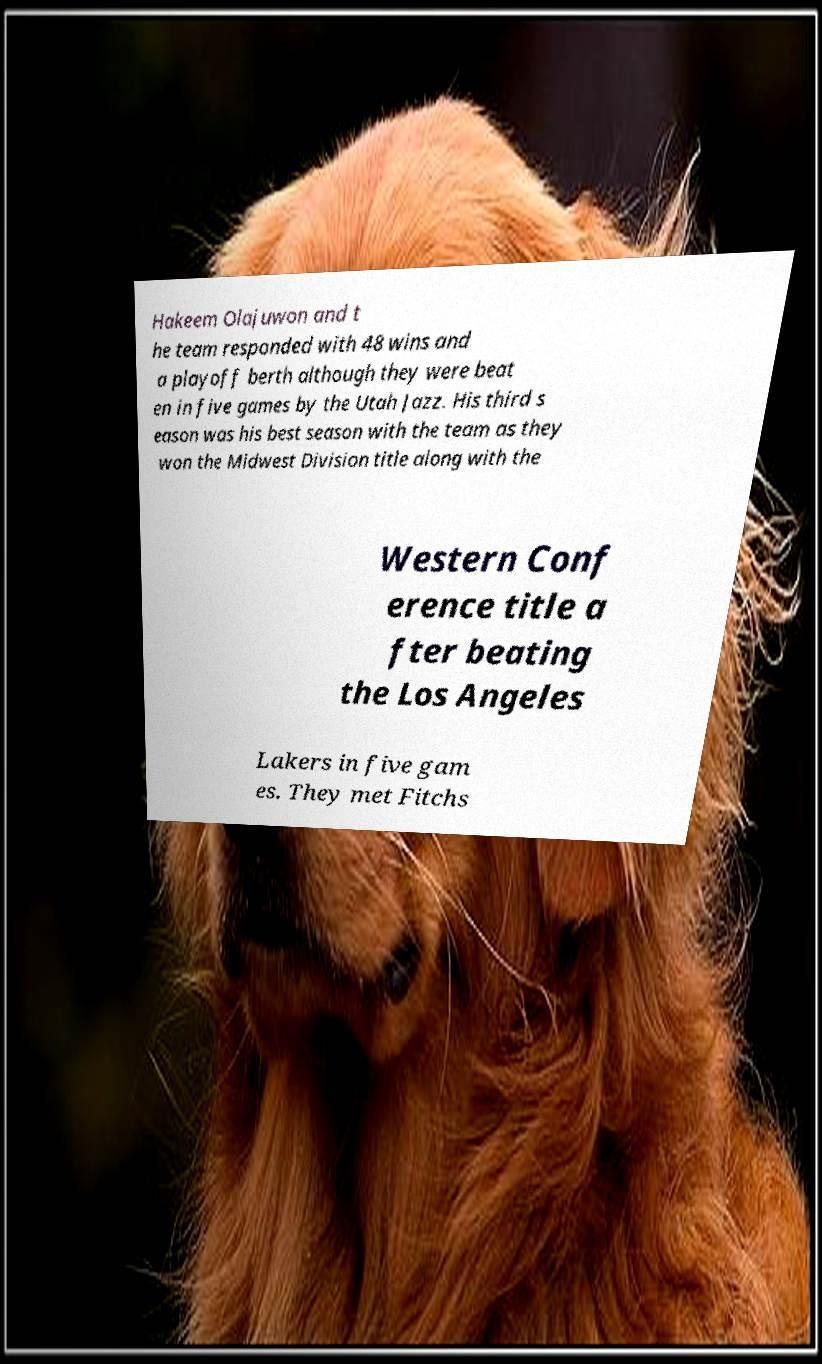Please identify and transcribe the text found in this image. Hakeem Olajuwon and t he team responded with 48 wins and a playoff berth although they were beat en in five games by the Utah Jazz. His third s eason was his best season with the team as they won the Midwest Division title along with the Western Conf erence title a fter beating the Los Angeles Lakers in five gam es. They met Fitchs 